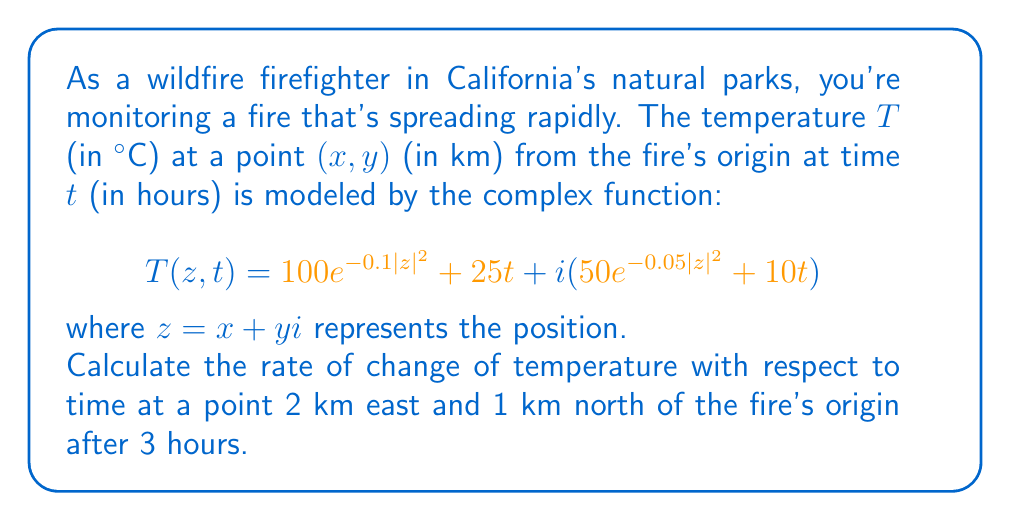Provide a solution to this math problem. To solve this problem, we need to follow these steps:

1) First, we need to find the partial derivative of T with respect to t:

   $$\frac{\partial T}{\partial t} = 25 + 10i$$

   This represents the rate of change of temperature with respect to time.

2) Now, we need to evaluate this at the given point and time:
   - The point is 2 km east and 1 km north, so $z = 2 + i$
   - The time t = 3 hours

3) However, we notice that the partial derivative is constant and doesn't depend on z or t. This means the rate of change of temperature with respect to time is the same everywhere and at all times.

4) Therefore, we can directly use the result from step 1:

   $$\frac{\partial T}{\partial t} = 25 + 10i$$

5) To interpret this:
   - The real part (25) represents the rate of change of the actual temperature in °C/hour.
   - The imaginary part (10) represents the rate of change of some other aspect of the fire, perhaps related to its intensity or spread.

6) In the context of the question, we're primarily interested in the real part, which is 25°C/hour.
Answer: 25 + 10i °C/hour, or more specifically, 25°C/hour for the actual temperature 